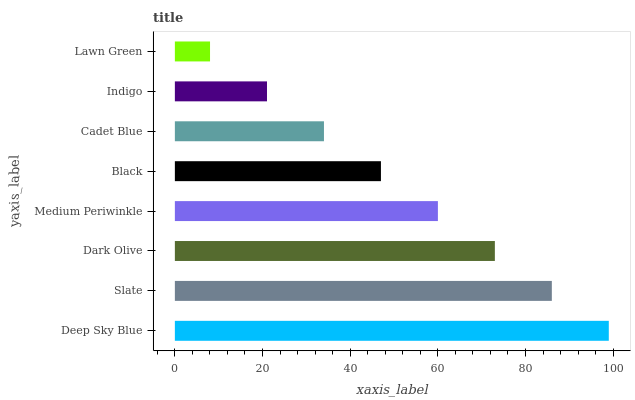Is Lawn Green the minimum?
Answer yes or no. Yes. Is Deep Sky Blue the maximum?
Answer yes or no. Yes. Is Slate the minimum?
Answer yes or no. No. Is Slate the maximum?
Answer yes or no. No. Is Deep Sky Blue greater than Slate?
Answer yes or no. Yes. Is Slate less than Deep Sky Blue?
Answer yes or no. Yes. Is Slate greater than Deep Sky Blue?
Answer yes or no. No. Is Deep Sky Blue less than Slate?
Answer yes or no. No. Is Medium Periwinkle the high median?
Answer yes or no. Yes. Is Black the low median?
Answer yes or no. Yes. Is Slate the high median?
Answer yes or no. No. Is Deep Sky Blue the low median?
Answer yes or no. No. 